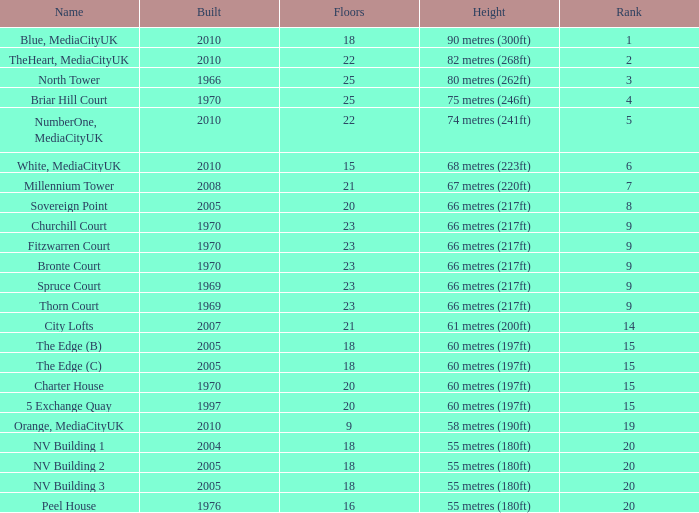What is the total number of Built, when Floors is less than 22, when Rank is less than 8, and when Name is White, Mediacityuk? 1.0. 